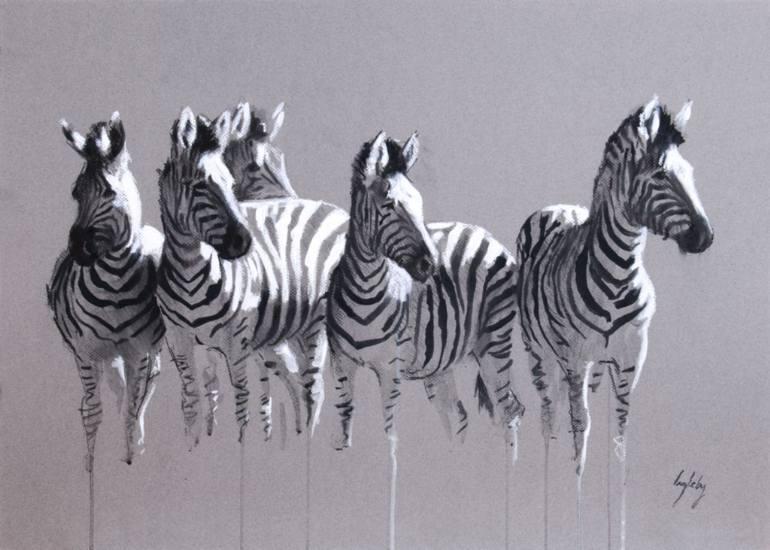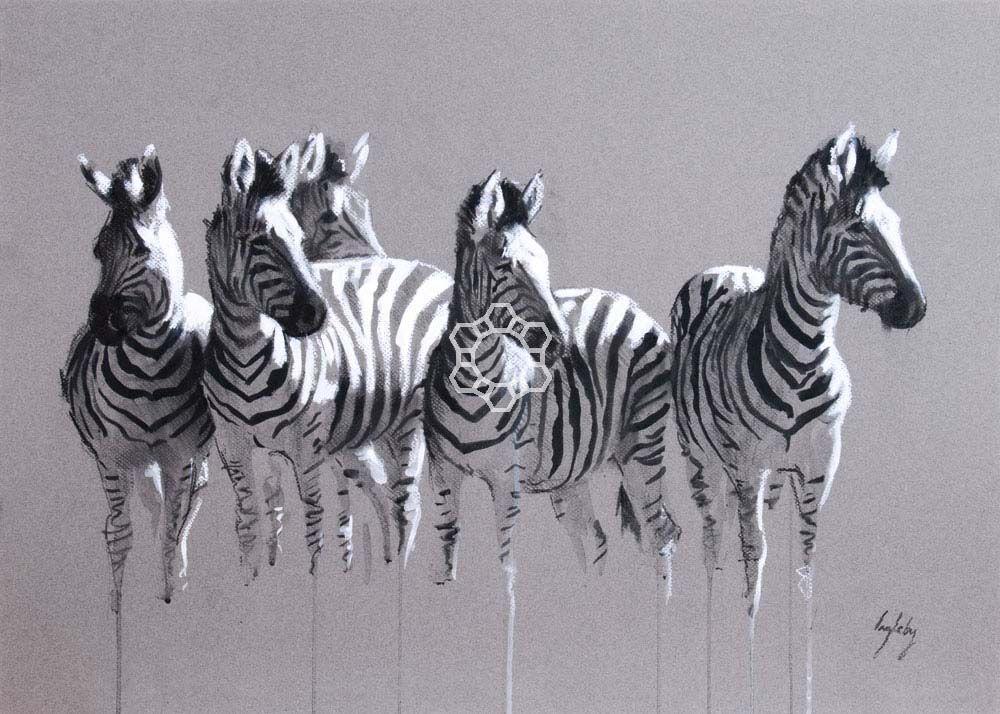The first image is the image on the left, the second image is the image on the right. Given the left and right images, does the statement "There is only one zebra in the right image." hold true? Answer yes or no. No. 